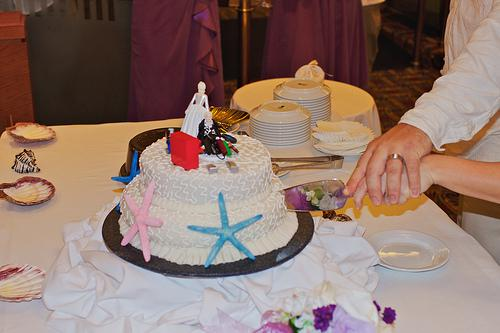Question: what kind of cake is it?
Choices:
A. Birthday cake.
B. Wedding cake.
C. Ice cream cake.
D. Carrot cake.
Answer with the letter. Answer: B Question: when does the cake get cut?
Choices:
A. After dinner.
B. At reception.
C. After candles are blown out.
D. When everyone leaves.
Answer with the letter. Answer: B Question: who is cutting the cake?
Choices:
A. Bride.
B. Groom.
C. Mother.
D. Father.
Answer with the letter. Answer: A Question: what is on the man's finger?
Choices:
A. A ring.
B. Frosting.
C. Paint.
D. Glue.
Answer with the letter. Answer: A 